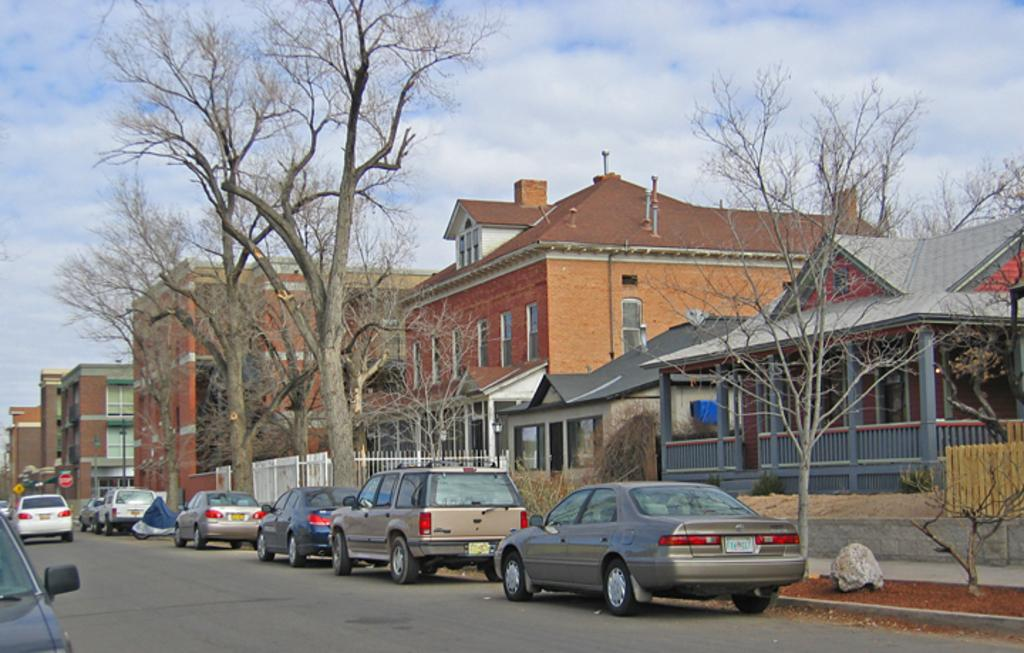What type of view is shown in the image? The image is an outside view. What can be seen on the road in the image? There are cars on the road in the image. What is visible in the background of the image? There are buildings and trees in the background of the image. What is visible at the top of the image? The sky is visible at the top of the image. What can be seen in the sky in the image? Clouds are present in the sky. What knowledge does the grandfather share with the spoon in the image? There is no grandfather or spoon present in the image. 